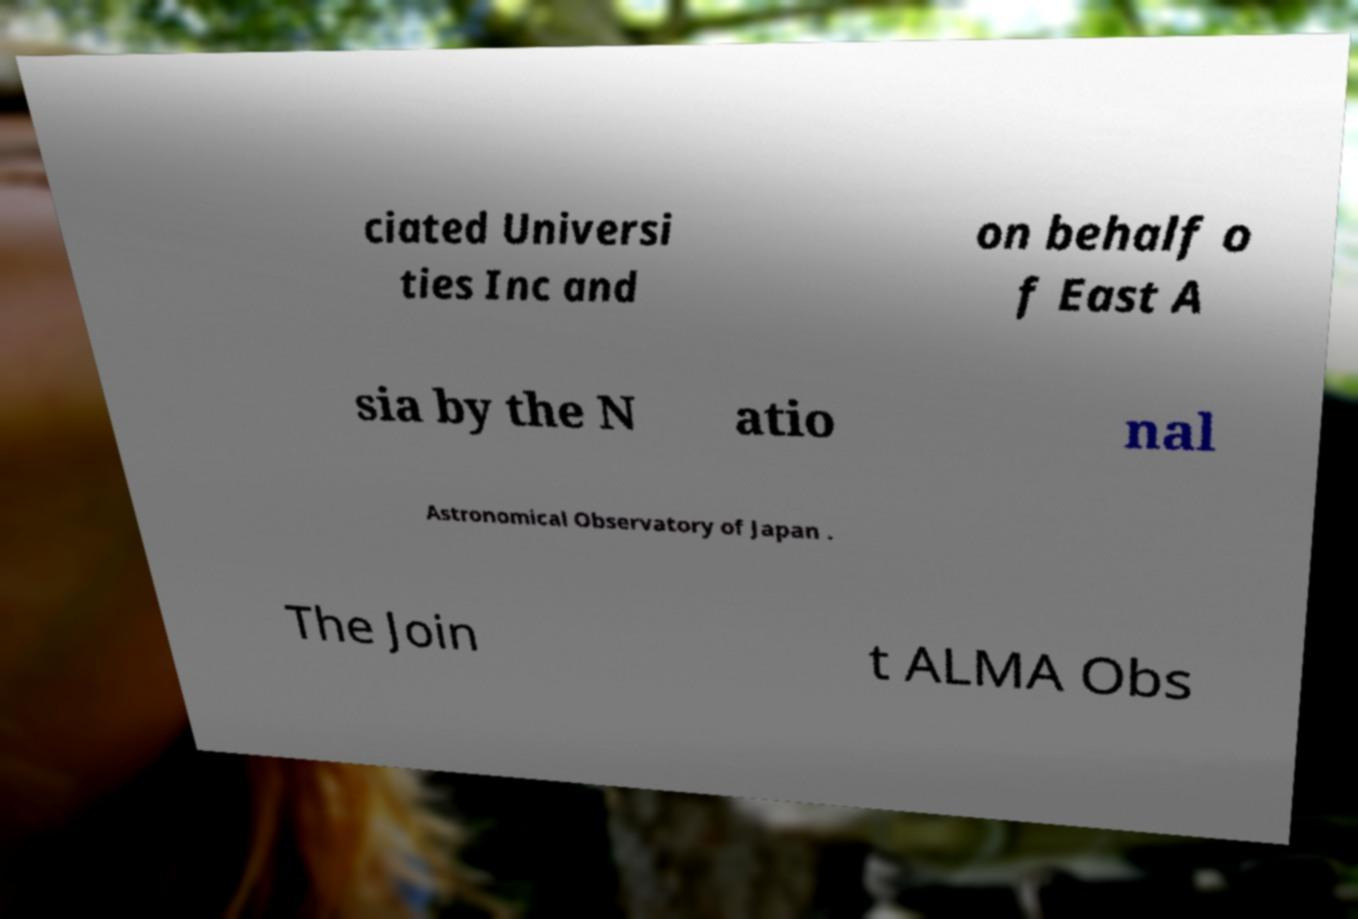There's text embedded in this image that I need extracted. Can you transcribe it verbatim? ciated Universi ties Inc and on behalf o f East A sia by the N atio nal Astronomical Observatory of Japan . The Join t ALMA Obs 